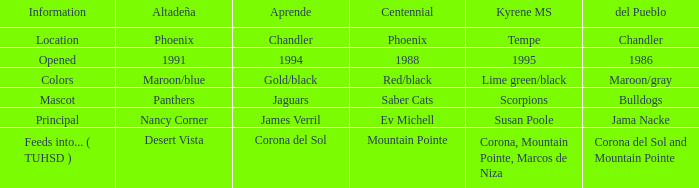What sort of altadeña is available at del pueblo in maroon/gray? Maroon/blue. 